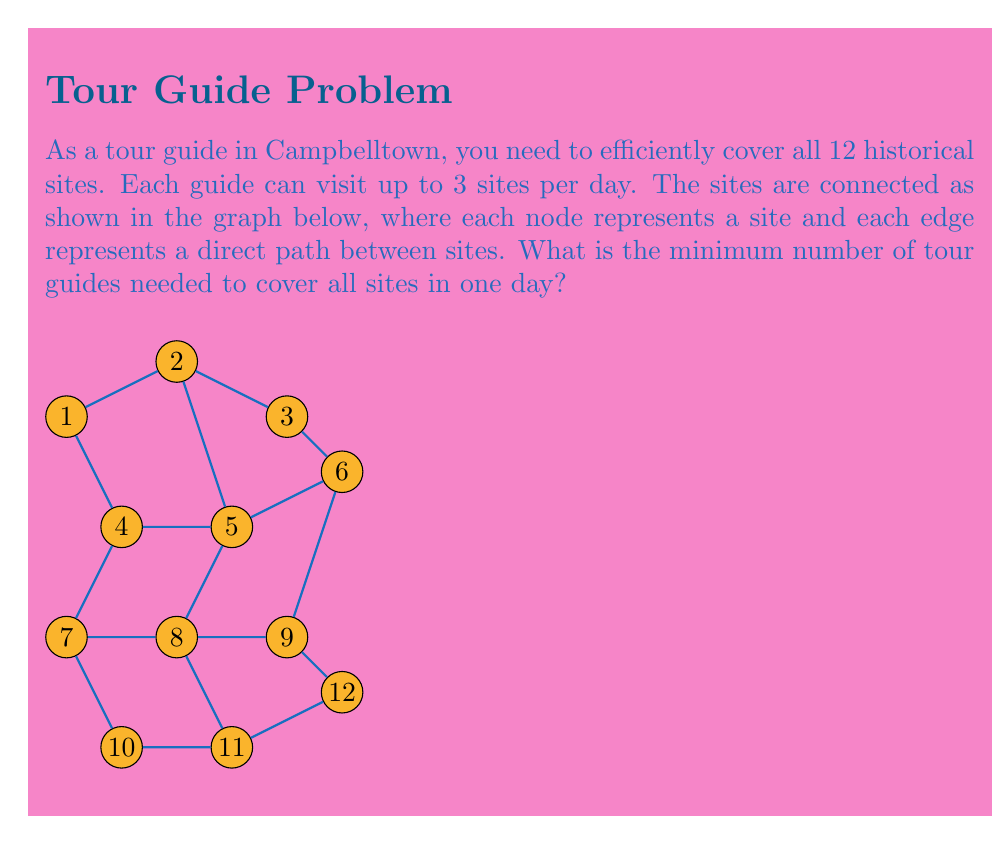Show me your answer to this math problem. To solve this problem, we can use the concept of vertex cover in graph theory. Here's the step-by-step approach:

1) First, we need to find a minimum vertex cover for the given graph. A vertex cover is a set of vertices such that each edge of the graph is incident to at least one vertex of the set.

2) Observe that the graph has a grid-like structure with some diagonals. We can cover all edges by selecting vertices in a pattern:

   - Select vertices 1, 3, 5, 7, 9, 11

3) This selection covers all edges in the graph, and no smaller set of vertices can do so. Therefore, this is a minimum vertex cover.

4) The size of this minimum vertex cover is 6.

5) Each tour guide can visit up to 3 sites per day. Therefore, to calculate the minimum number of guides needed, we divide the size of the vertex cover by 3 and round up to the nearest integer:

   $$\text{Number of guides} = \left\lceil\frac{6}{3}\right\rceil = 2$$

6) Therefore, a minimum of 2 tour guides are needed to cover all historical sites in Campbelltown in one day.

This solution ensures that all sites are visited and all connections between sites are covered efficiently.
Answer: 2 guides 